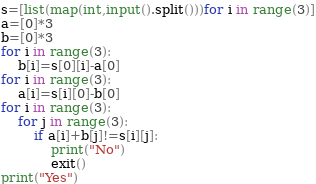<code> <loc_0><loc_0><loc_500><loc_500><_Python_>s=[list(map(int,input().split()))for i in range(3)]
a=[0]*3
b=[0]*3
for i in range(3):
    b[i]=s[0][i]-a[0]
for i in range(3):
    a[i]=s[i][0]-b[0]
for i in range(3):
    for j in range(3):
        if a[i]+b[j]!=s[i][j]:
            print("No")
            exit()
print("Yes")</code> 